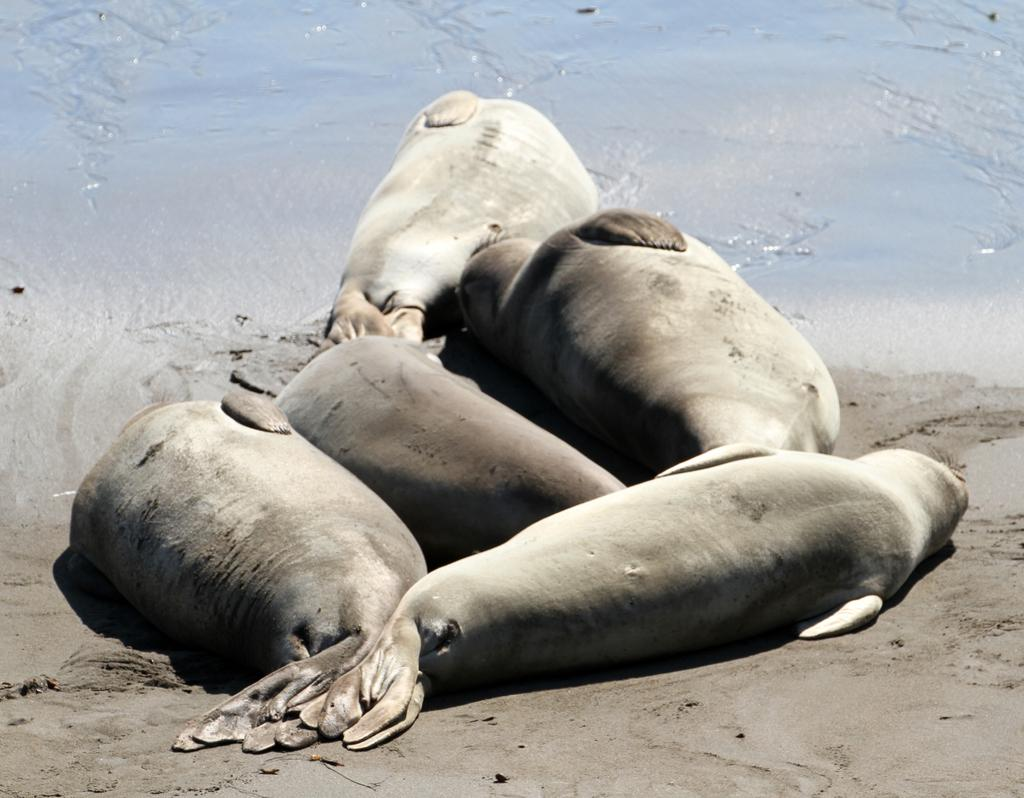What animals are in the center of the image? There are seals in the center of the image. What type of environment is visible in the image? There is water visible at the top side of the image. What type of pot is being used for educational purposes in the image? There is no pot or educational activity present in the image. 